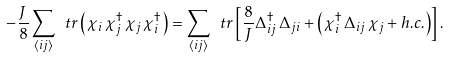Convert formula to latex. <formula><loc_0><loc_0><loc_500><loc_500>- \frac { J } { 8 } \sum _ { \langle i j \rangle } \ t r \left ( \chi _ { i } \, \chi _ { j } ^ { \dagger } \, \chi _ { j } \, \chi _ { i } ^ { \dagger } \right ) = \sum _ { \langle i j \rangle } \ t r \left [ \frac { 8 } { J } \Delta _ { i j } ^ { \dagger } \, \Delta _ { j i } + \left ( \chi _ { i } ^ { \dagger } \, \Delta _ { i j } \, \chi _ { j } + h . c . \right ) \right ] .</formula> 